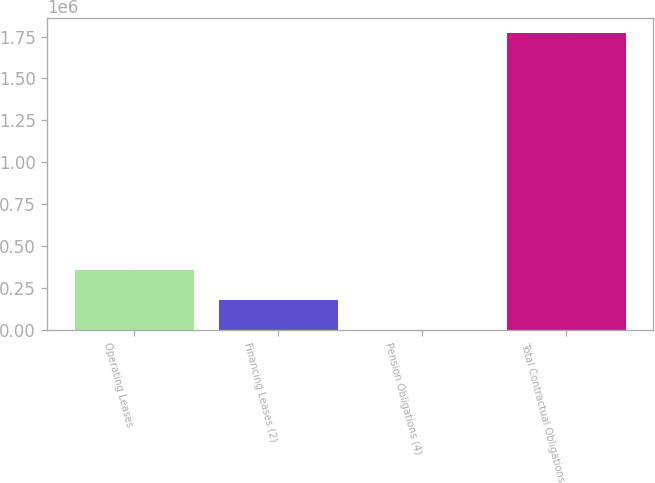<chart> <loc_0><loc_0><loc_500><loc_500><bar_chart><fcel>Operating Leases<fcel>Financing Leases (2)<fcel>Pension Obligations (4)<fcel>Total Contractual Obligations<nl><fcel>354648<fcel>177728<fcel>809<fcel>1.77e+06<nl></chart> 